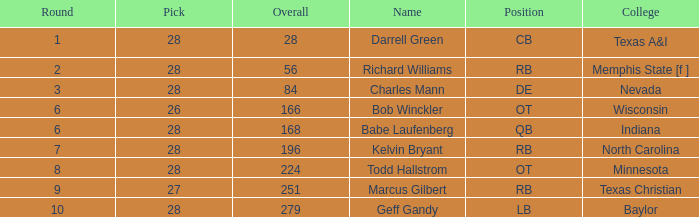What is the lowest round of the position de player with an overall less than 84? None. 